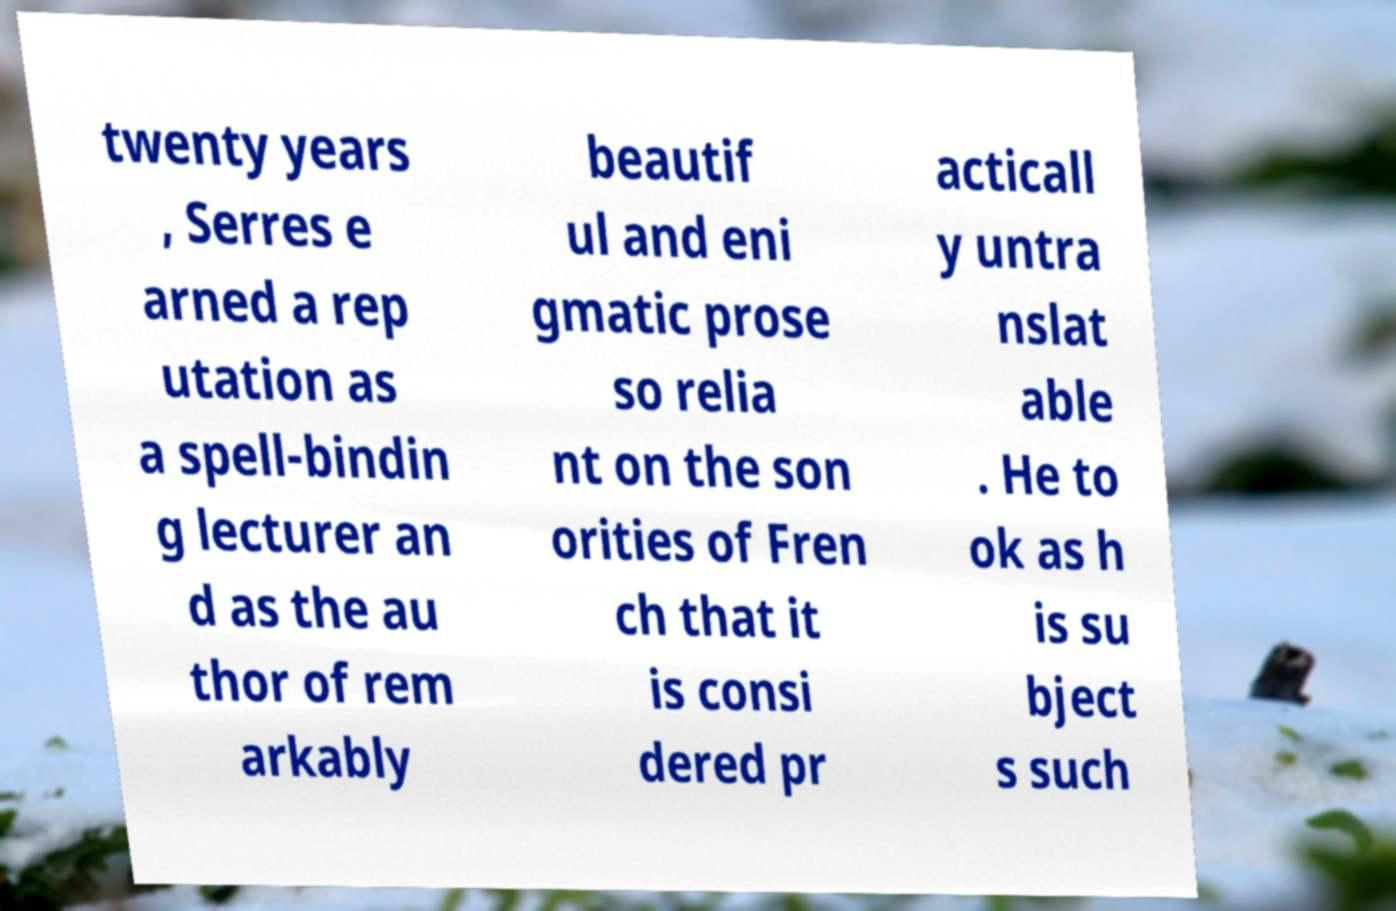Can you read and provide the text displayed in the image?This photo seems to have some interesting text. Can you extract and type it out for me? twenty years , Serres e arned a rep utation as a spell-bindin g lecturer an d as the au thor of rem arkably beautif ul and eni gmatic prose so relia nt on the son orities of Fren ch that it is consi dered pr acticall y untra nslat able . He to ok as h is su bject s such 